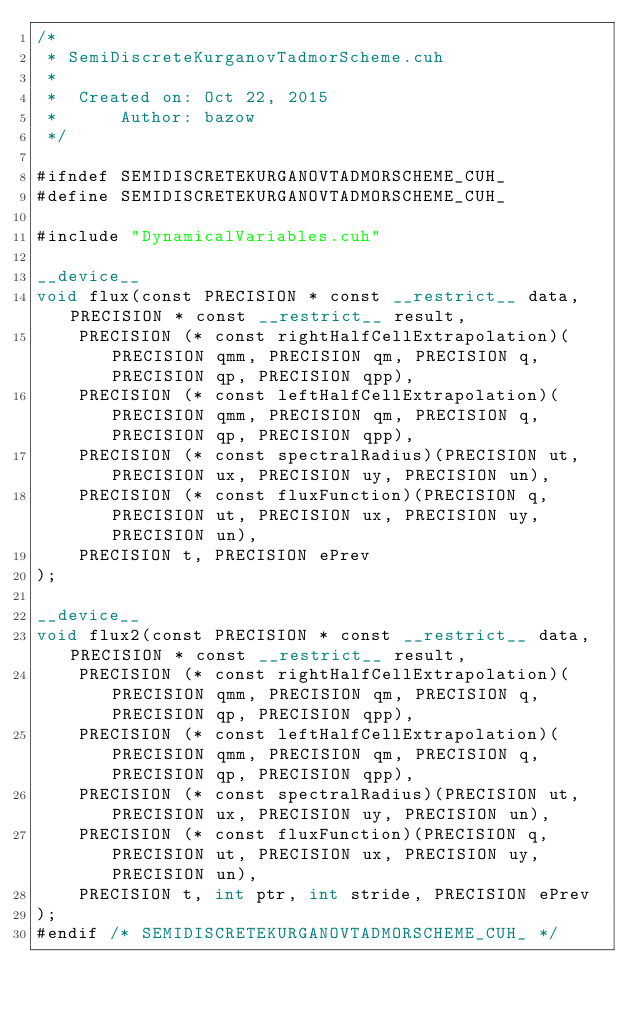Convert code to text. <code><loc_0><loc_0><loc_500><loc_500><_Cuda_>/*
 * SemiDiscreteKurganovTadmorScheme.cuh
 *
 *  Created on: Oct 22, 2015
 *      Author: bazow
 */

#ifndef SEMIDISCRETEKURGANOVTADMORSCHEME_CUH_
#define SEMIDISCRETEKURGANOVTADMORSCHEME_CUH_

#include "DynamicalVariables.cuh"

__device__
void flux(const PRECISION * const __restrict__ data, PRECISION * const __restrict__ result,
		PRECISION (* const rightHalfCellExtrapolation)(PRECISION qmm, PRECISION qm, PRECISION q, PRECISION qp, PRECISION qpp),
		PRECISION (* const leftHalfCellExtrapolation)(PRECISION qmm, PRECISION qm, PRECISION q, PRECISION qp, PRECISION qpp),
		PRECISION (* const spectralRadius)(PRECISION ut, PRECISION ux, PRECISION uy, PRECISION un),
		PRECISION (* const fluxFunction)(PRECISION q, PRECISION ut, PRECISION ux, PRECISION uy, PRECISION un),
		PRECISION t, PRECISION ePrev
);

__device__
void flux2(const PRECISION * const __restrict__ data, PRECISION * const __restrict__ result,
		PRECISION (* const rightHalfCellExtrapolation)(PRECISION qmm, PRECISION qm, PRECISION q, PRECISION qp, PRECISION qpp),
		PRECISION (* const leftHalfCellExtrapolation)(PRECISION qmm, PRECISION qm, PRECISION q, PRECISION qp, PRECISION qpp),
		PRECISION (* const spectralRadius)(PRECISION ut, PRECISION ux, PRECISION uy, PRECISION un),
		PRECISION (* const fluxFunction)(PRECISION q, PRECISION ut, PRECISION ux, PRECISION uy, PRECISION un),
		PRECISION t, int ptr, int stride, PRECISION ePrev
);
#endif /* SEMIDISCRETEKURGANOVTADMORSCHEME_CUH_ */
</code> 